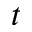Convert formula to latex. <formula><loc_0><loc_0><loc_500><loc_500>t</formula> 